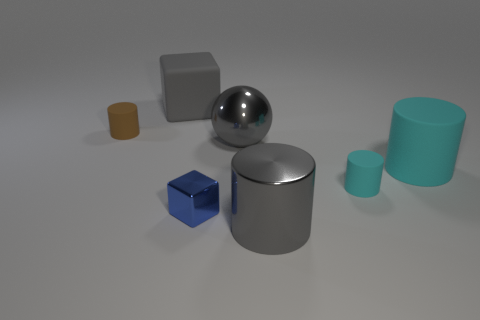What is the material of the big cylinder that is the same color as the large ball?
Make the answer very short. Metal. How many other objects are the same material as the big block?
Make the answer very short. 3. There is a small thing behind the big cyan rubber cylinder; what number of tiny metallic cubes are in front of it?
Your response must be concise. 1. What number of cylinders are tiny brown things or green rubber objects?
Provide a short and direct response. 1. The object that is both in front of the large cube and left of the tiny metal thing is what color?
Ensure brevity in your answer.  Brown. Is there any other thing of the same color as the metal sphere?
Give a very brief answer. Yes. The small rubber thing that is to the right of the gray cube behind the gray metallic cylinder is what color?
Provide a succinct answer. Cyan. Is the blue shiny object the same size as the gray block?
Make the answer very short. No. Is the material of the large ball that is right of the brown cylinder the same as the small cylinder to the left of the big gray rubber cube?
Your answer should be compact. No. The thing that is behind the rubber cylinder left of the block that is on the left side of the shiny cube is what shape?
Provide a succinct answer. Cube. 